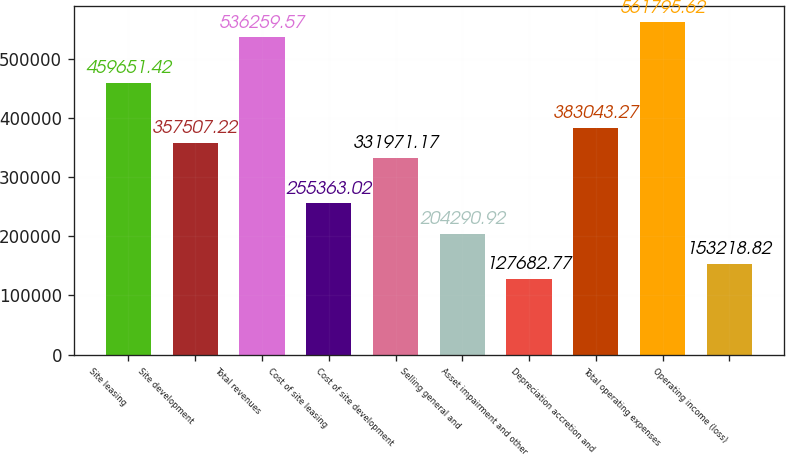<chart> <loc_0><loc_0><loc_500><loc_500><bar_chart><fcel>Site leasing<fcel>Site development<fcel>Total revenues<fcel>Cost of site leasing<fcel>Cost of site development<fcel>Selling general and<fcel>Asset impairment and other<fcel>Depreciation accretion and<fcel>Total operating expenses<fcel>Operating income (loss)<nl><fcel>459651<fcel>357507<fcel>536260<fcel>255363<fcel>331971<fcel>204291<fcel>127683<fcel>383043<fcel>561796<fcel>153219<nl></chart> 